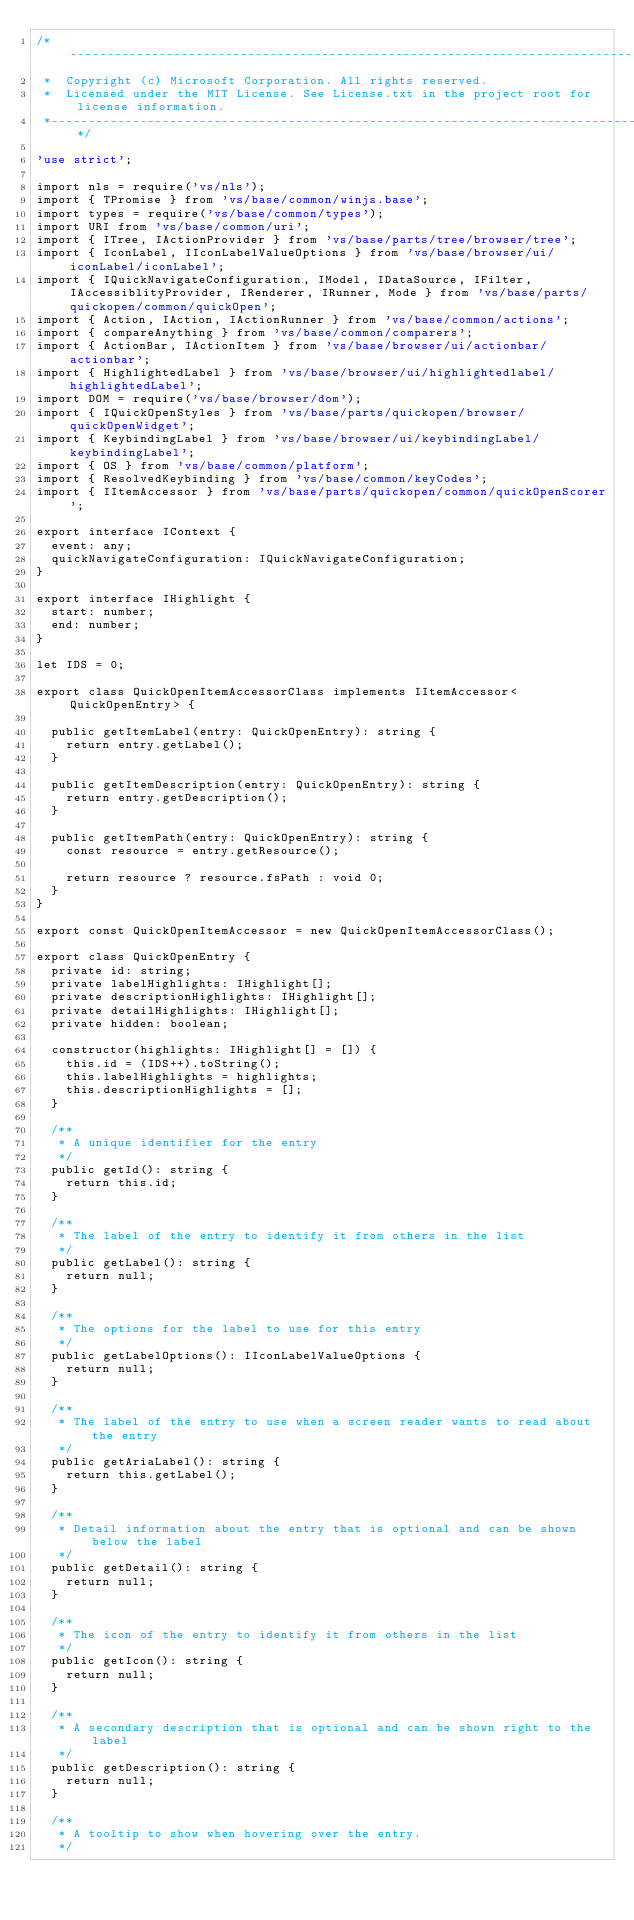<code> <loc_0><loc_0><loc_500><loc_500><_TypeScript_>/*---------------------------------------------------------------------------------------------
 *  Copyright (c) Microsoft Corporation. All rights reserved.
 *  Licensed under the MIT License. See License.txt in the project root for license information.
 *--------------------------------------------------------------------------------------------*/

'use strict';

import nls = require('vs/nls');
import { TPromise } from 'vs/base/common/winjs.base';
import types = require('vs/base/common/types');
import URI from 'vs/base/common/uri';
import { ITree, IActionProvider } from 'vs/base/parts/tree/browser/tree';
import { IconLabel, IIconLabelValueOptions } from 'vs/base/browser/ui/iconLabel/iconLabel';
import { IQuickNavigateConfiguration, IModel, IDataSource, IFilter, IAccessiblityProvider, IRenderer, IRunner, Mode } from 'vs/base/parts/quickopen/common/quickOpen';
import { Action, IAction, IActionRunner } from 'vs/base/common/actions';
import { compareAnything } from 'vs/base/common/comparers';
import { ActionBar, IActionItem } from 'vs/base/browser/ui/actionbar/actionbar';
import { HighlightedLabel } from 'vs/base/browser/ui/highlightedlabel/highlightedLabel';
import DOM = require('vs/base/browser/dom');
import { IQuickOpenStyles } from 'vs/base/parts/quickopen/browser/quickOpenWidget';
import { KeybindingLabel } from 'vs/base/browser/ui/keybindingLabel/keybindingLabel';
import { OS } from 'vs/base/common/platform';
import { ResolvedKeybinding } from 'vs/base/common/keyCodes';
import { IItemAccessor } from 'vs/base/parts/quickopen/common/quickOpenScorer';

export interface IContext {
	event: any;
	quickNavigateConfiguration: IQuickNavigateConfiguration;
}

export interface IHighlight {
	start: number;
	end: number;
}

let IDS = 0;

export class QuickOpenItemAccessorClass implements IItemAccessor<QuickOpenEntry> {

	public getItemLabel(entry: QuickOpenEntry): string {
		return entry.getLabel();
	}

	public getItemDescription(entry: QuickOpenEntry): string {
		return entry.getDescription();
	}

	public getItemPath(entry: QuickOpenEntry): string {
		const resource = entry.getResource();

		return resource ? resource.fsPath : void 0;
	}
}

export const QuickOpenItemAccessor = new QuickOpenItemAccessorClass();

export class QuickOpenEntry {
	private id: string;
	private labelHighlights: IHighlight[];
	private descriptionHighlights: IHighlight[];
	private detailHighlights: IHighlight[];
	private hidden: boolean;

	constructor(highlights: IHighlight[] = []) {
		this.id = (IDS++).toString();
		this.labelHighlights = highlights;
		this.descriptionHighlights = [];
	}

	/**
	 * A unique identifier for the entry
	 */
	public getId(): string {
		return this.id;
	}

	/**
	 * The label of the entry to identify it from others in the list
	 */
	public getLabel(): string {
		return null;
	}

	/**
	 * The options for the label to use for this entry
	 */
	public getLabelOptions(): IIconLabelValueOptions {
		return null;
	}

	/**
	 * The label of the entry to use when a screen reader wants to read about the entry
	 */
	public getAriaLabel(): string {
		return this.getLabel();
	}

	/**
	 * Detail information about the entry that is optional and can be shown below the label
	 */
	public getDetail(): string {
		return null;
	}

	/**
	 * The icon of the entry to identify it from others in the list
	 */
	public getIcon(): string {
		return null;
	}

	/**
	 * A secondary description that is optional and can be shown right to the label
	 */
	public getDescription(): string {
		return null;
	}

	/**
	 * A tooltip to show when hovering over the entry.
	 */</code> 